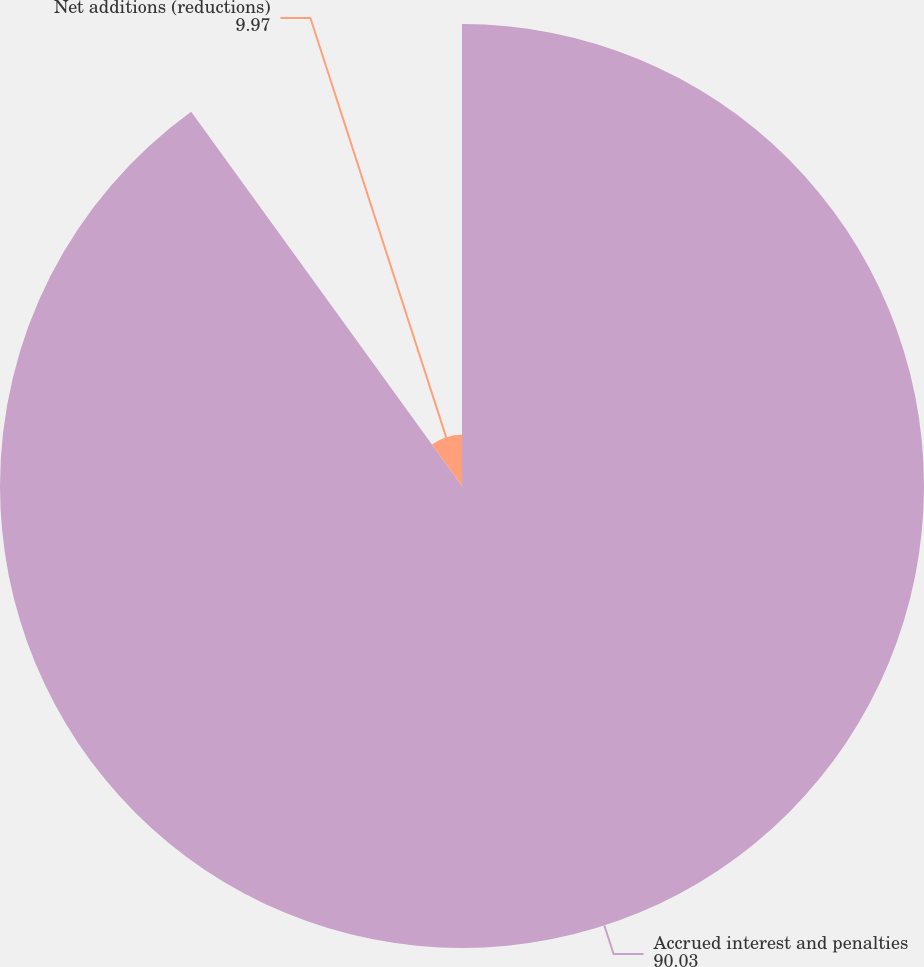<chart> <loc_0><loc_0><loc_500><loc_500><pie_chart><fcel>Accrued interest and penalties<fcel>Net additions (reductions)<nl><fcel>90.03%<fcel>9.97%<nl></chart> 